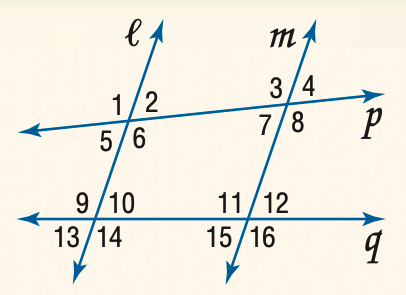Question: Find the measure of \angle 6 if l \parallel m and m \angle 1 = 105.
Choices:
A. 75
B. 85
C. 95
D. 105
Answer with the letter. Answer: D 